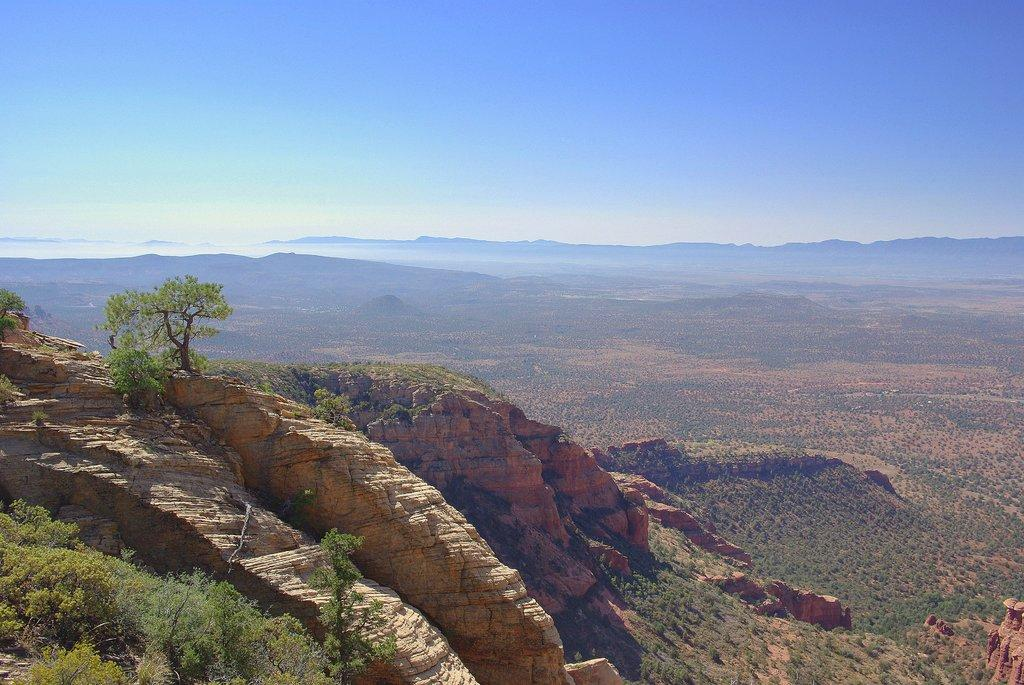What type of natural features can be seen in the image? There are rocks and trees in the image. What can be seen in the distance in the image? There are mountains in the background of the image. What is visible in the sky in the image? The sky is visible in the background of the image. What type of horn can be heard in the image? There is no horn present in the image, and therefore no sound can be heard. 